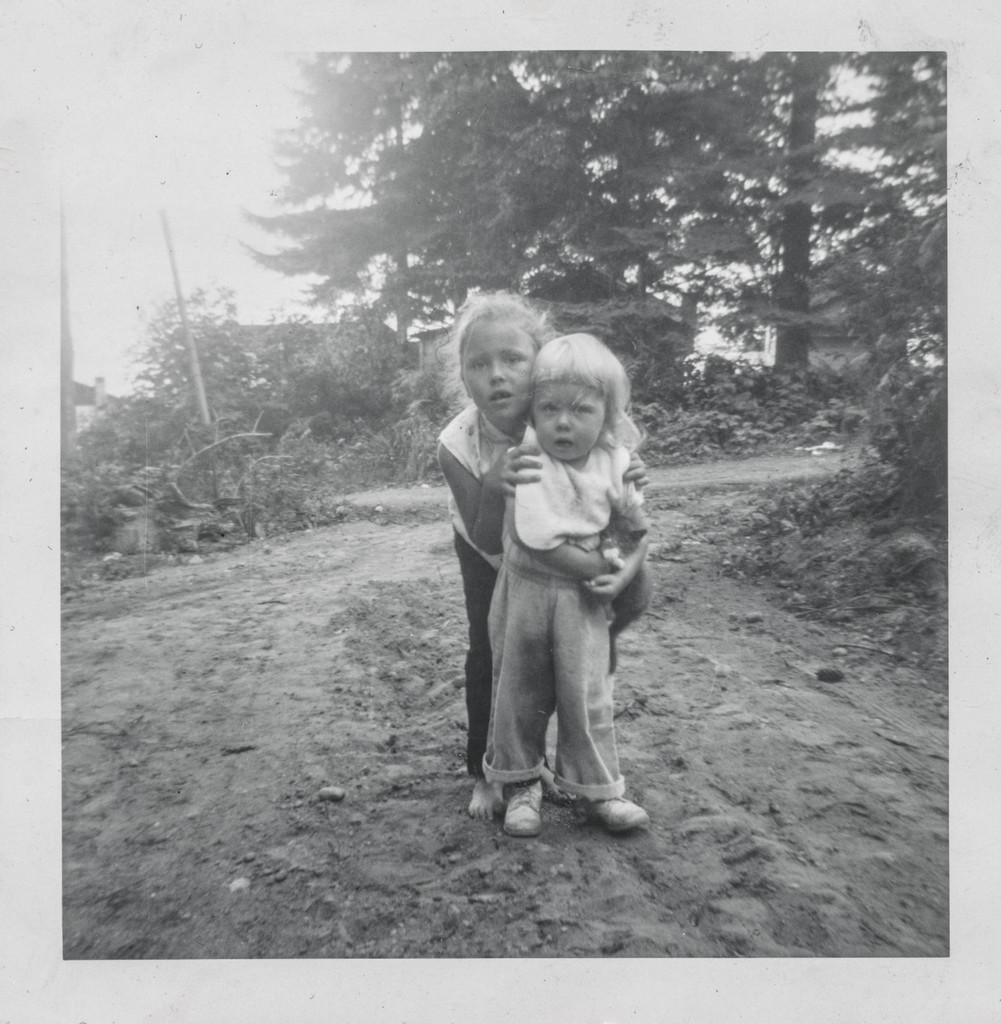What is the color scheme of the image? The image is black and white. How many kids are present in the image? There are two kids in the image. What is the position of the kids in relation to each other? The kids are standing one after the other. What can be seen in the background of the image? There are trees in the background of the image. What type of ground is visible in the image set on? The ground is covered with sand. What type of wire is being used for treatment in the image? There is no wire or treatment present in the image; it features two kids standing one after the other with trees in the background and sandy ground? 